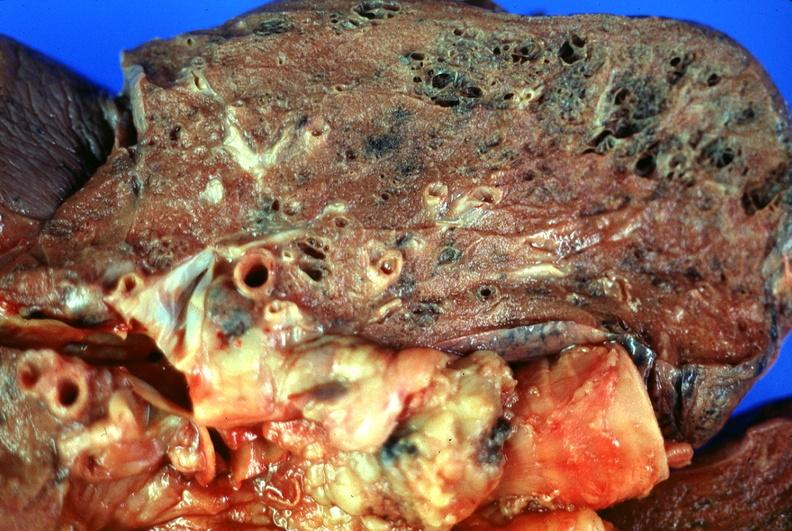does this image show lung, emphysema?
Answer the question using a single word or phrase. Yes 